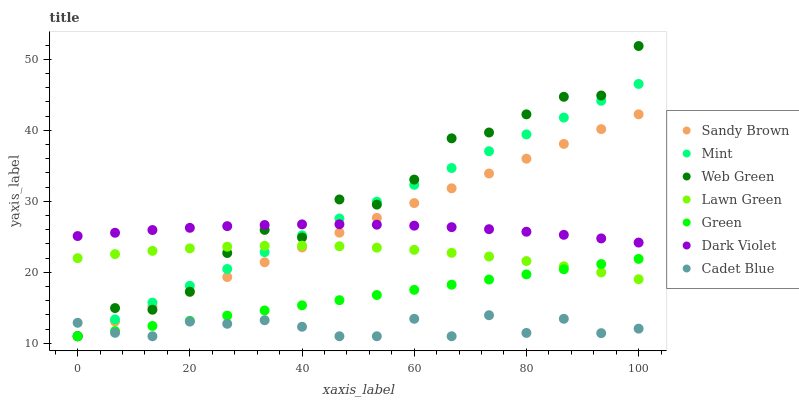Does Cadet Blue have the minimum area under the curve?
Answer yes or no. Yes. Does Web Green have the maximum area under the curve?
Answer yes or no. Yes. Does Sandy Brown have the minimum area under the curve?
Answer yes or no. No. Does Sandy Brown have the maximum area under the curve?
Answer yes or no. No. Is Mint the smoothest?
Answer yes or no. Yes. Is Web Green the roughest?
Answer yes or no. Yes. Is Cadet Blue the smoothest?
Answer yes or no. No. Is Cadet Blue the roughest?
Answer yes or no. No. Does Cadet Blue have the lowest value?
Answer yes or no. Yes. Does Dark Violet have the lowest value?
Answer yes or no. No. Does Web Green have the highest value?
Answer yes or no. Yes. Does Sandy Brown have the highest value?
Answer yes or no. No. Is Cadet Blue less than Dark Violet?
Answer yes or no. Yes. Is Lawn Green greater than Cadet Blue?
Answer yes or no. Yes. Does Sandy Brown intersect Web Green?
Answer yes or no. Yes. Is Sandy Brown less than Web Green?
Answer yes or no. No. Is Sandy Brown greater than Web Green?
Answer yes or no. No. Does Cadet Blue intersect Dark Violet?
Answer yes or no. No. 